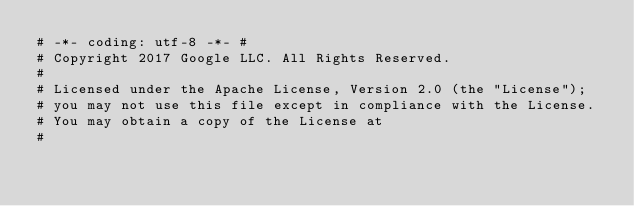<code> <loc_0><loc_0><loc_500><loc_500><_Python_># -*- coding: utf-8 -*- #
# Copyright 2017 Google LLC. All Rights Reserved.
#
# Licensed under the Apache License, Version 2.0 (the "License");
# you may not use this file except in compliance with the License.
# You may obtain a copy of the License at
#</code> 